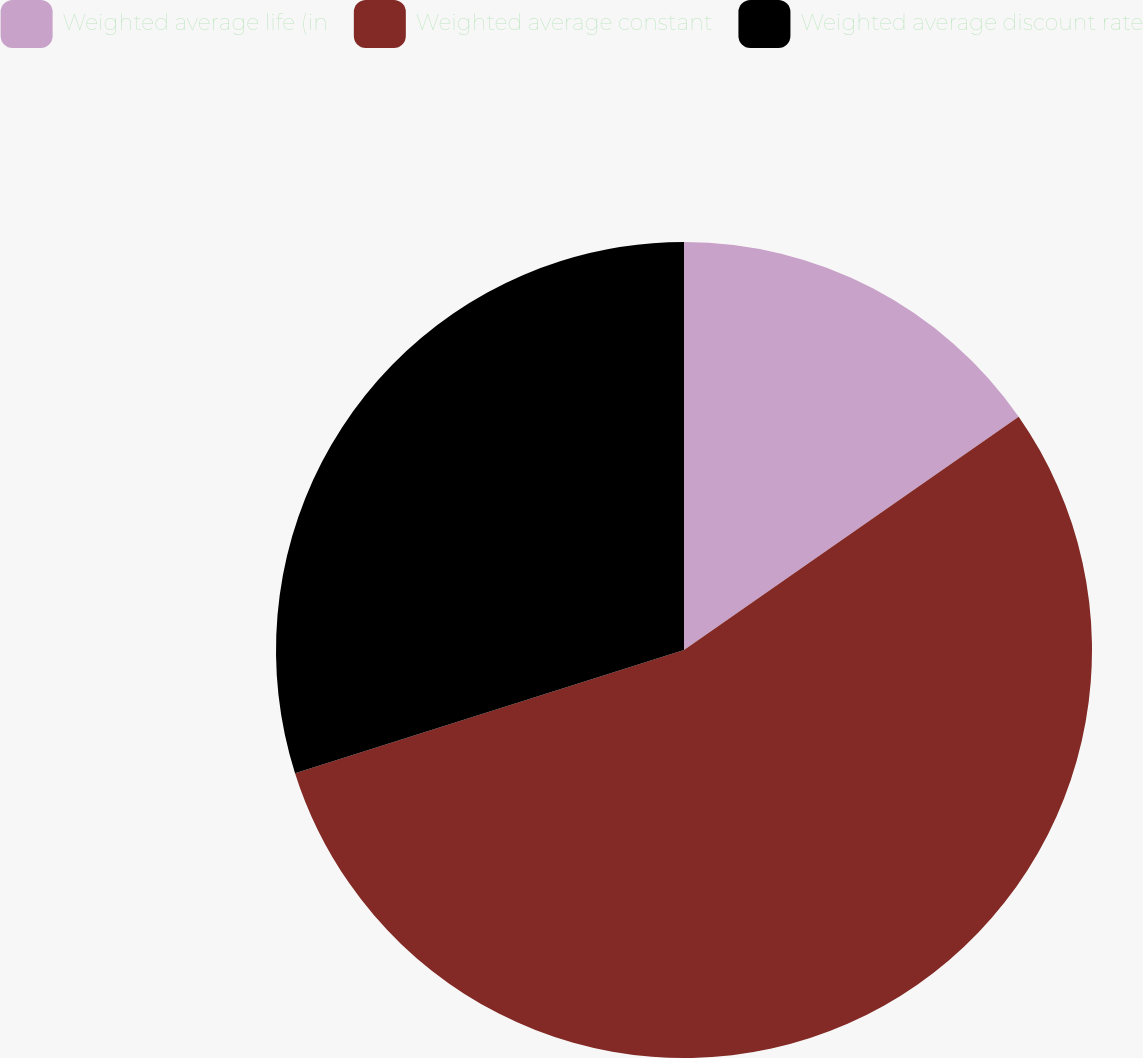<chart> <loc_0><loc_0><loc_500><loc_500><pie_chart><fcel>Weighted average life (in<fcel>Weighted average constant<fcel>Weighted average discount rate<nl><fcel>15.31%<fcel>54.81%<fcel>29.88%<nl></chart> 